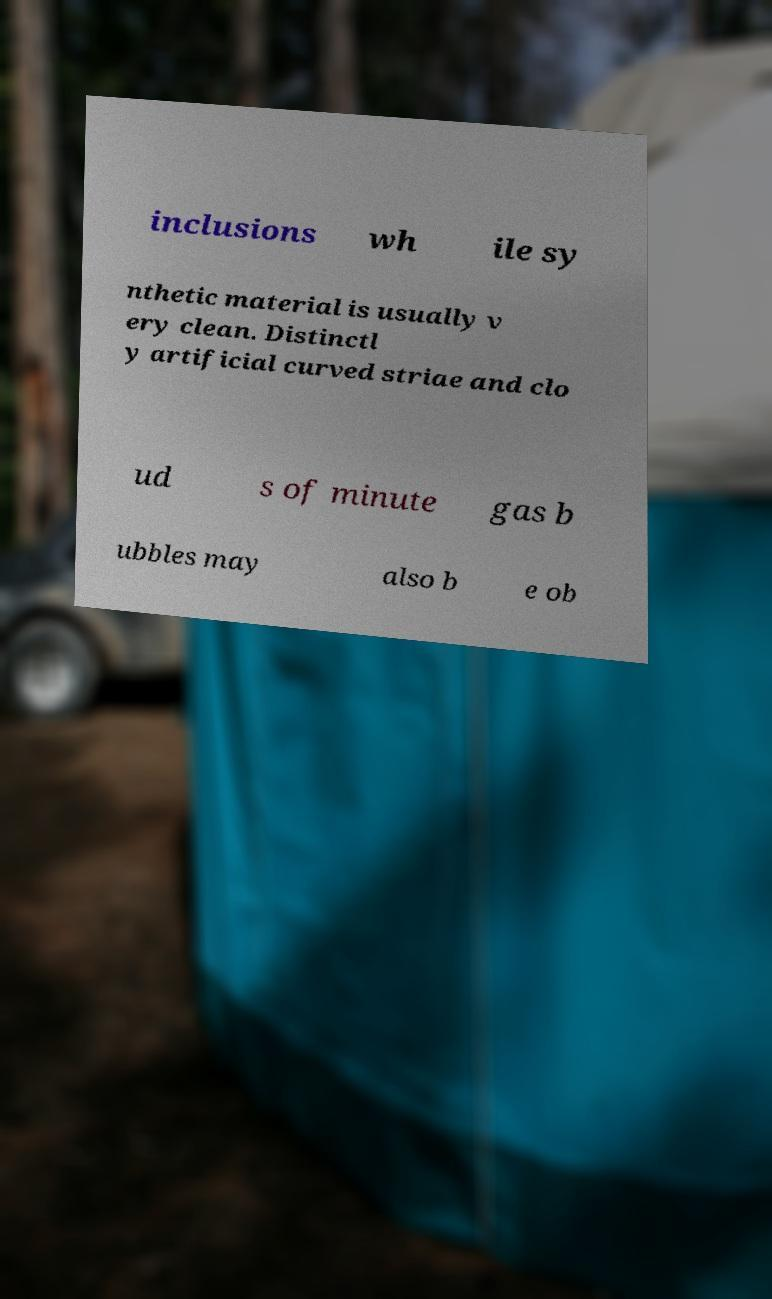Please identify and transcribe the text found in this image. inclusions wh ile sy nthetic material is usually v ery clean. Distinctl y artificial curved striae and clo ud s of minute gas b ubbles may also b e ob 